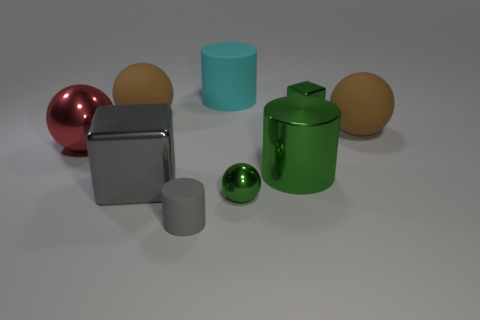Add 1 big metal things. How many objects exist? 10 Subtract all balls. How many objects are left? 5 Subtract 0 purple blocks. How many objects are left? 9 Subtract all cyan objects. Subtract all tiny purple matte objects. How many objects are left? 8 Add 1 small rubber things. How many small rubber things are left? 2 Add 3 metal things. How many metal things exist? 8 